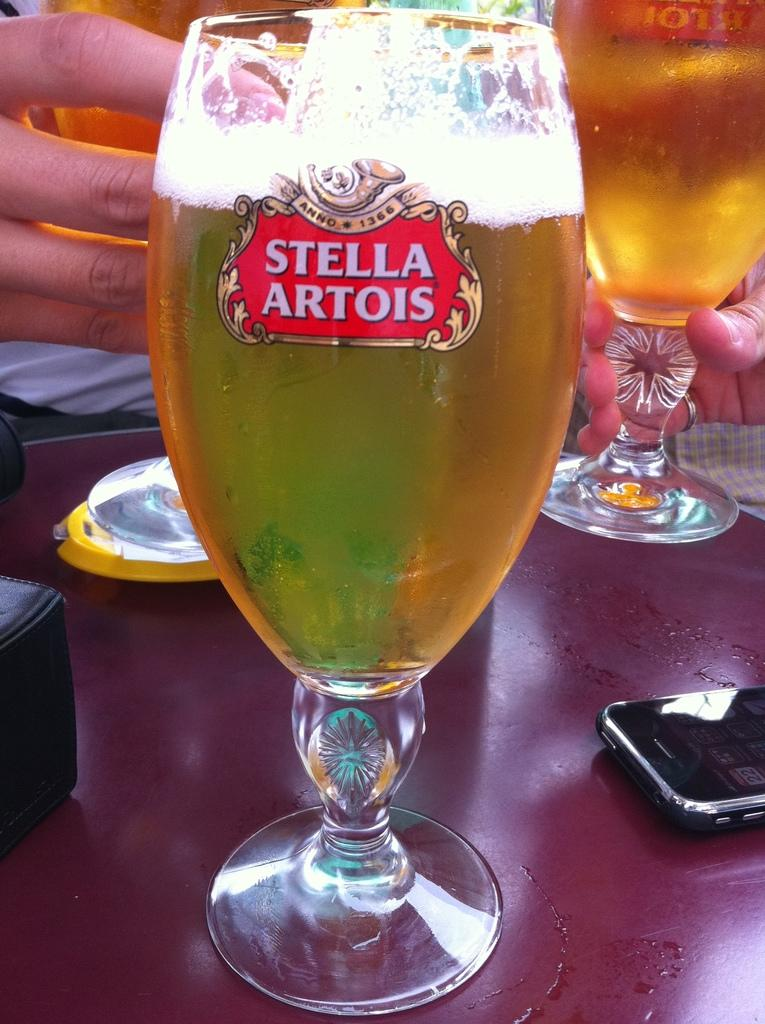Provide a one-sentence caption for the provided image. Beer is filled in a tall glass that reads "Stella Artois". 